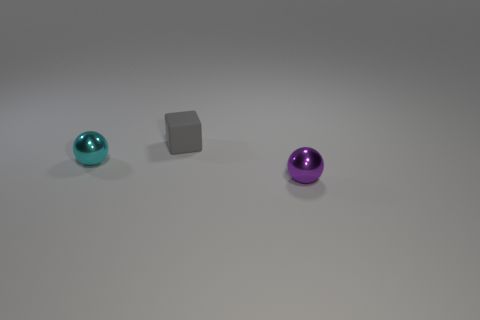What could be the purpose of these objects? Based on the image alone, it's not possible to determine their specific purpose, but they could serve as decorative items, be part of a visual arts project, or be used in a game or a physics simulation demonstrating properties like shape, light, and shadow. If these were used in a physics simulation, what might be demonstrated? In a physics simulation, these objects could be used to demonstrate various principles, like the behavior of different shapes under the influence of forces, how light interacts with surfaces of different textures, or simply to display the effect of gravity on objects with different mass distributions. 